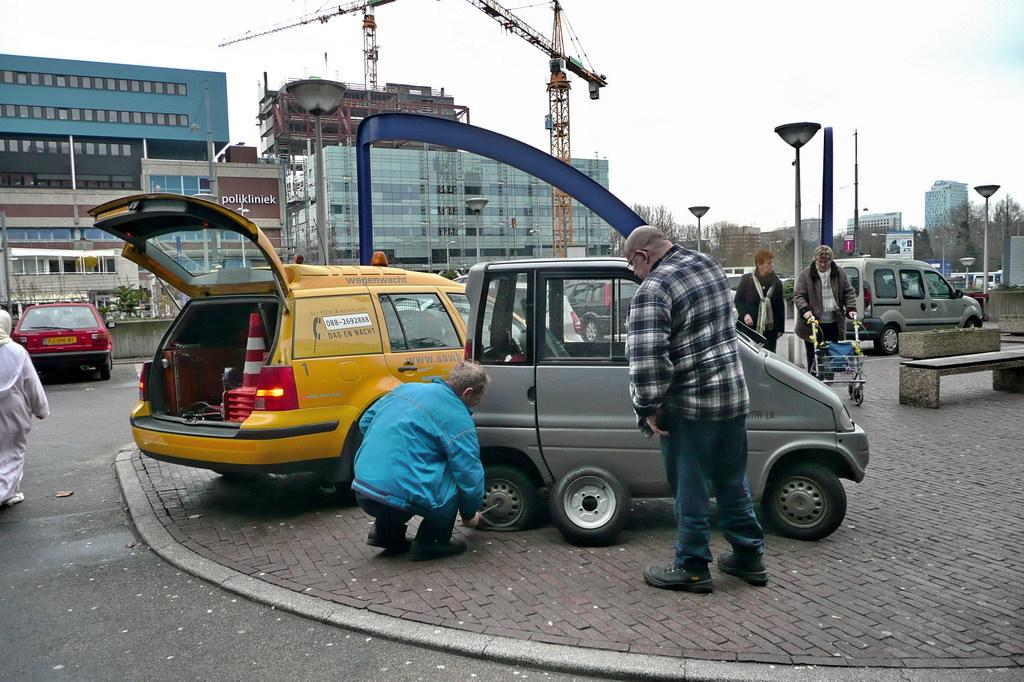<image>
Give a short and clear explanation of the subsequent image. Two men are working to repair a flat tire and the repair vehicle says wegenwacht. 